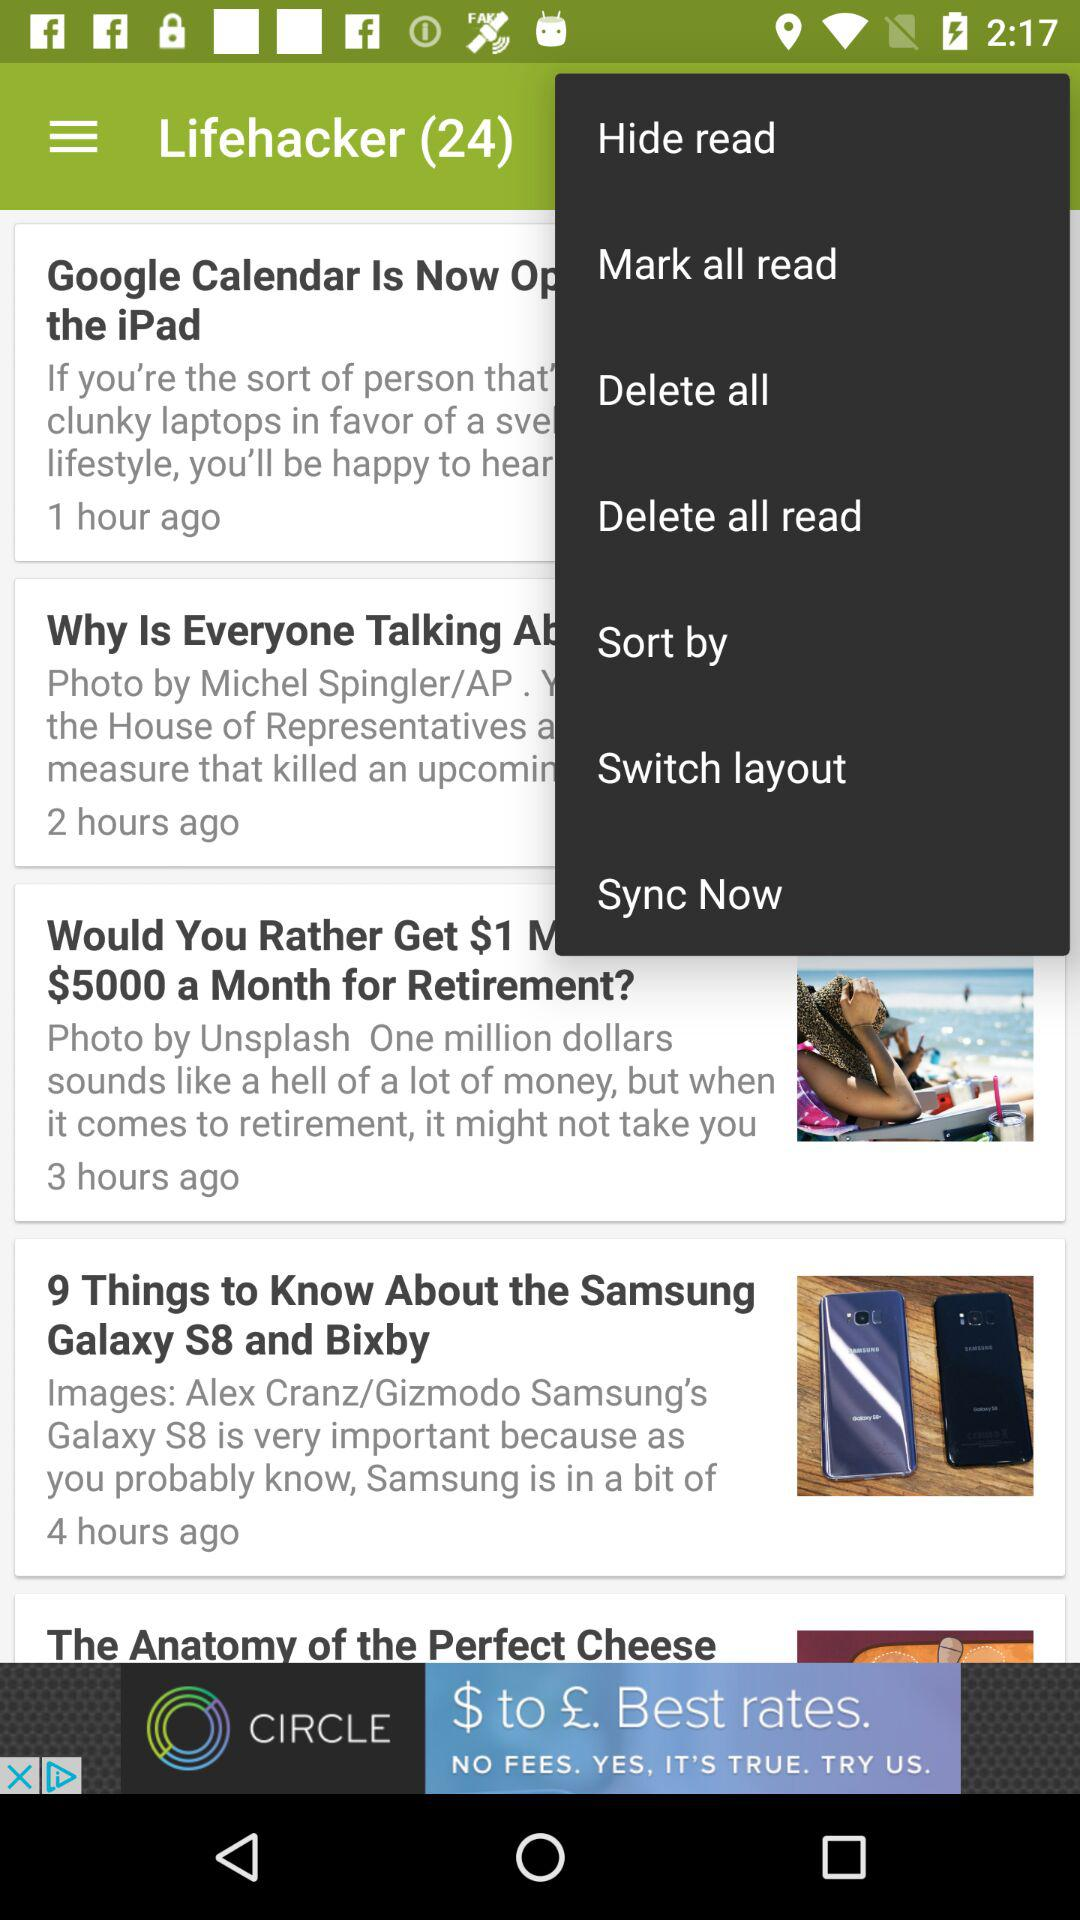How many posts are there in "Lifehacker"? There are 24 posts. 